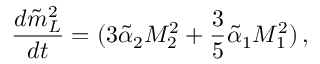Convert formula to latex. <formula><loc_0><loc_0><loc_500><loc_500>\frac { d \tilde { m } _ { L } ^ { 2 } } { d t } = ( 3 \tilde { \alpha } _ { 2 } M _ { 2 } ^ { 2 } + \frac { 3 } { 5 } \tilde { \alpha } _ { 1 } M _ { 1 } ^ { 2 } ) \, ,</formula> 